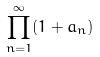Convert formula to latex. <formula><loc_0><loc_0><loc_500><loc_500>\prod _ { n = 1 } ^ { \infty } ( 1 + a _ { n } )</formula> 